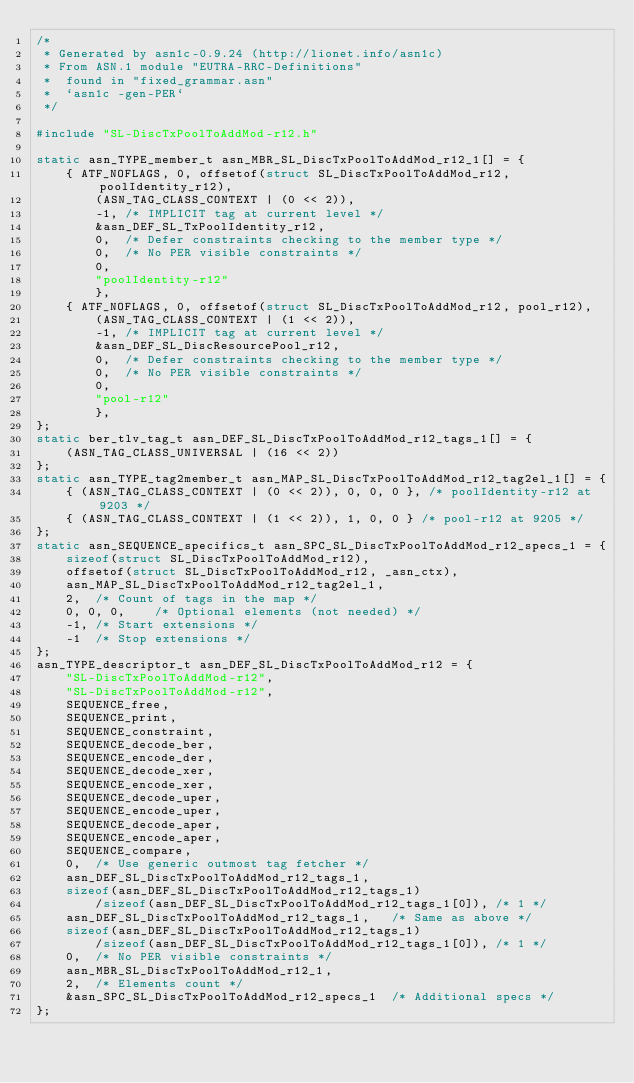<code> <loc_0><loc_0><loc_500><loc_500><_C_>/*
 * Generated by asn1c-0.9.24 (http://lionet.info/asn1c)
 * From ASN.1 module "EUTRA-RRC-Definitions"
 * 	found in "fixed_grammar.asn"
 * 	`asn1c -gen-PER`
 */

#include "SL-DiscTxPoolToAddMod-r12.h"

static asn_TYPE_member_t asn_MBR_SL_DiscTxPoolToAddMod_r12_1[] = {
	{ ATF_NOFLAGS, 0, offsetof(struct SL_DiscTxPoolToAddMod_r12, poolIdentity_r12),
		(ASN_TAG_CLASS_CONTEXT | (0 << 2)),
		-1,	/* IMPLICIT tag at current level */
		&asn_DEF_SL_TxPoolIdentity_r12,
		0,	/* Defer constraints checking to the member type */
		0,	/* No PER visible constraints */
		0,
		"poolIdentity-r12"
		},
	{ ATF_NOFLAGS, 0, offsetof(struct SL_DiscTxPoolToAddMod_r12, pool_r12),
		(ASN_TAG_CLASS_CONTEXT | (1 << 2)),
		-1,	/* IMPLICIT tag at current level */
		&asn_DEF_SL_DiscResourcePool_r12,
		0,	/* Defer constraints checking to the member type */
		0,	/* No PER visible constraints */
		0,
		"pool-r12"
		},
};
static ber_tlv_tag_t asn_DEF_SL_DiscTxPoolToAddMod_r12_tags_1[] = {
	(ASN_TAG_CLASS_UNIVERSAL | (16 << 2))
};
static asn_TYPE_tag2member_t asn_MAP_SL_DiscTxPoolToAddMod_r12_tag2el_1[] = {
    { (ASN_TAG_CLASS_CONTEXT | (0 << 2)), 0, 0, 0 }, /* poolIdentity-r12 at 9203 */
    { (ASN_TAG_CLASS_CONTEXT | (1 << 2)), 1, 0, 0 } /* pool-r12 at 9205 */
};
static asn_SEQUENCE_specifics_t asn_SPC_SL_DiscTxPoolToAddMod_r12_specs_1 = {
	sizeof(struct SL_DiscTxPoolToAddMod_r12),
	offsetof(struct SL_DiscTxPoolToAddMod_r12, _asn_ctx),
	asn_MAP_SL_DiscTxPoolToAddMod_r12_tag2el_1,
	2,	/* Count of tags in the map */
	0, 0, 0,	/* Optional elements (not needed) */
	-1,	/* Start extensions */
	-1	/* Stop extensions */
};
asn_TYPE_descriptor_t asn_DEF_SL_DiscTxPoolToAddMod_r12 = {
	"SL-DiscTxPoolToAddMod-r12",
	"SL-DiscTxPoolToAddMod-r12",
	SEQUENCE_free,
	SEQUENCE_print,
	SEQUENCE_constraint,
	SEQUENCE_decode_ber,
	SEQUENCE_encode_der,
	SEQUENCE_decode_xer,
	SEQUENCE_encode_xer,
	SEQUENCE_decode_uper,
	SEQUENCE_encode_uper,
	SEQUENCE_decode_aper,
	SEQUENCE_encode_aper,
	SEQUENCE_compare,
	0,	/* Use generic outmost tag fetcher */
	asn_DEF_SL_DiscTxPoolToAddMod_r12_tags_1,
	sizeof(asn_DEF_SL_DiscTxPoolToAddMod_r12_tags_1)
		/sizeof(asn_DEF_SL_DiscTxPoolToAddMod_r12_tags_1[0]), /* 1 */
	asn_DEF_SL_DiscTxPoolToAddMod_r12_tags_1,	/* Same as above */
	sizeof(asn_DEF_SL_DiscTxPoolToAddMod_r12_tags_1)
		/sizeof(asn_DEF_SL_DiscTxPoolToAddMod_r12_tags_1[0]), /* 1 */
	0,	/* No PER visible constraints */
	asn_MBR_SL_DiscTxPoolToAddMod_r12_1,
	2,	/* Elements count */
	&asn_SPC_SL_DiscTxPoolToAddMod_r12_specs_1	/* Additional specs */
};

</code> 